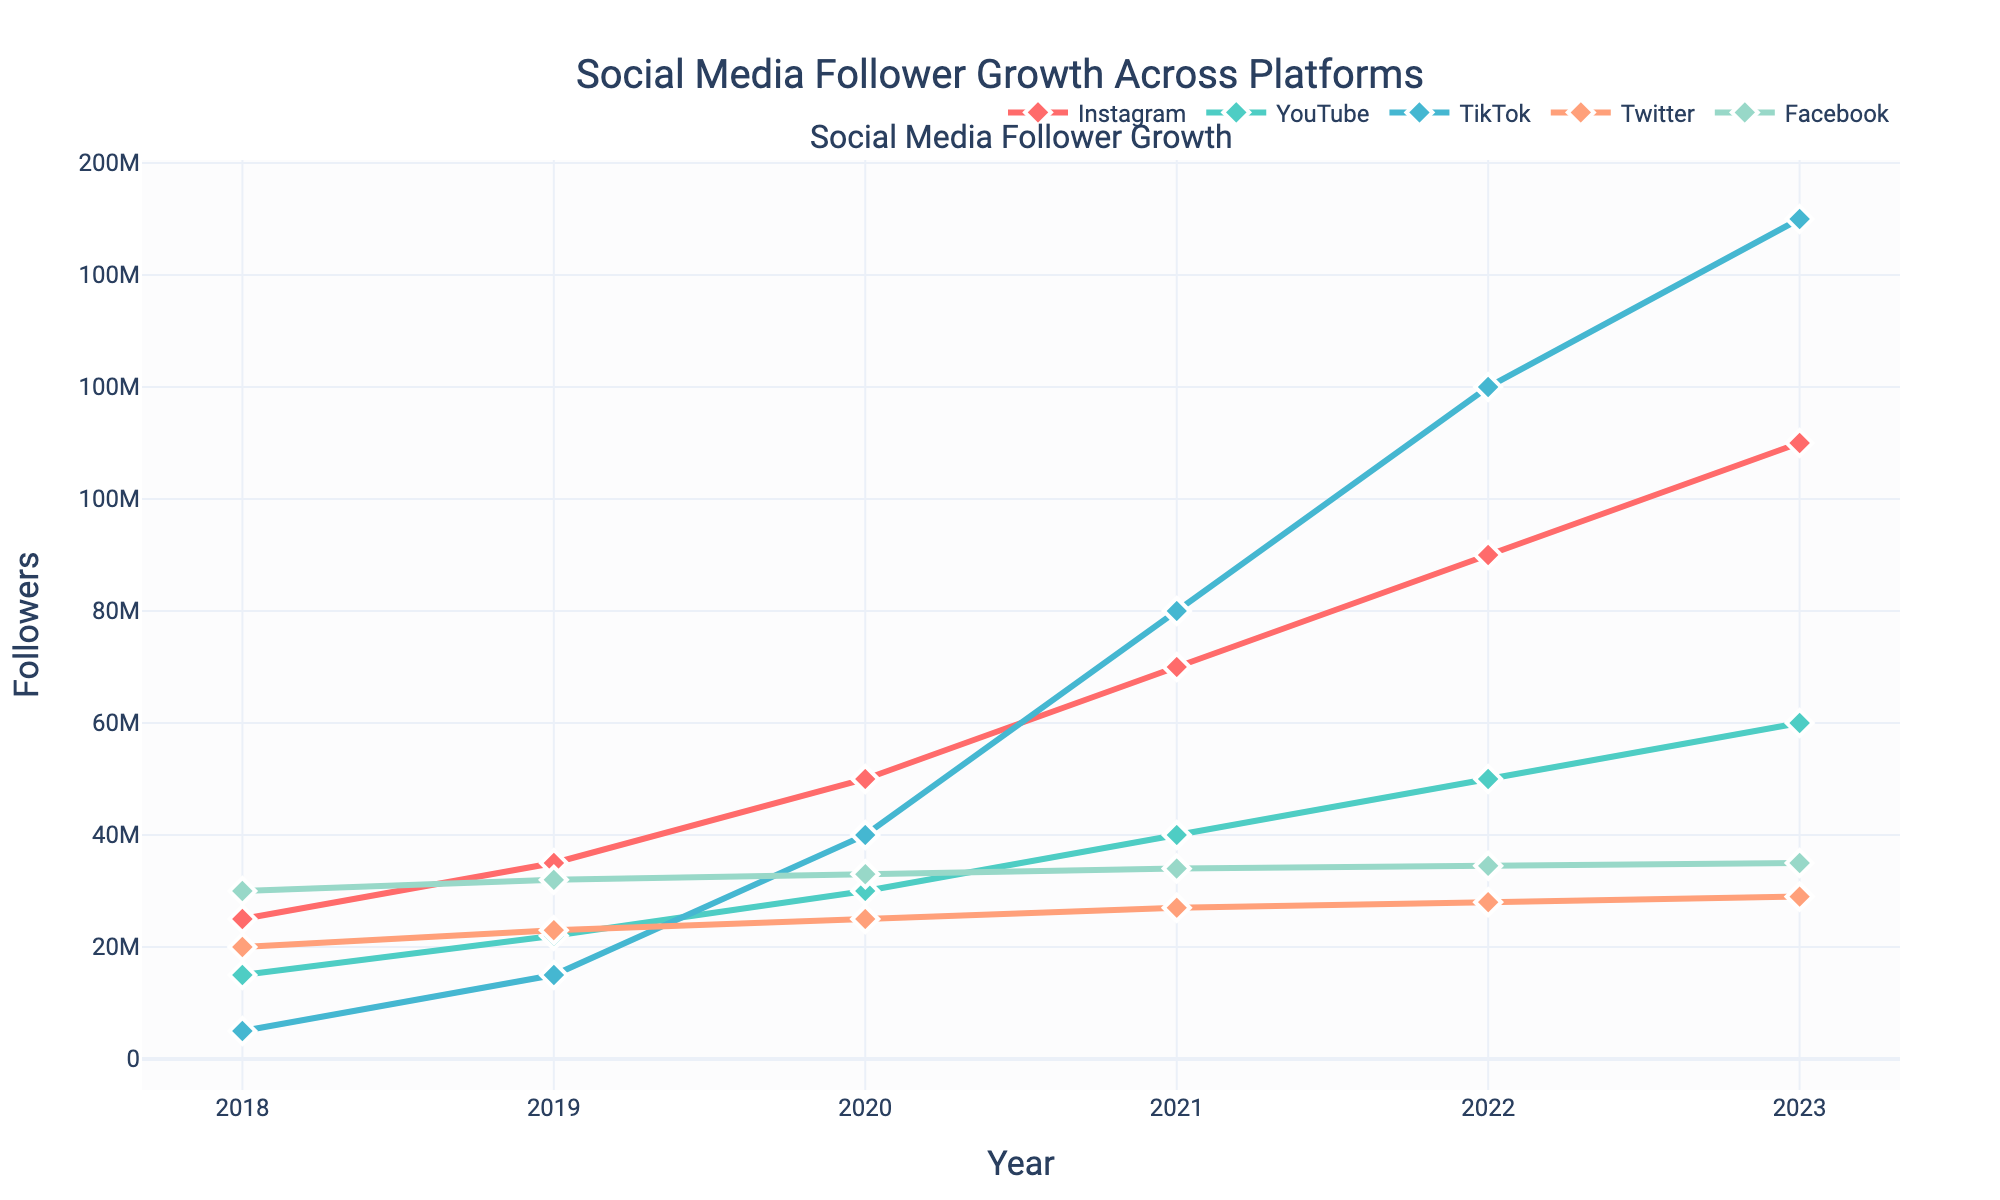What was the follower count for Instagram in 2020? Look at the line for Instagram in the year 2020; the data point shows 50,000,000 followers.
Answer: 50,000,000 How many more followers did TikTok have than YouTube in 2022? In 2022, TikTok had 120,000,000 followers and YouTube had 50,000,000. The difference is 120,000,000 - 50,000,000 = 70,000,000 followers.
Answer: 70,000,000 Which social media platform experienced the highest growth in followers between 2021 and 2023? Compare the follower counts in 2021 and 2023 for all platforms. TikTok grew from 80,000,000 to 150,000,000, yielding the highest growth of 70,000,000 followers.
Answer: TikTok What is the average follower count for Facebook over the 5 years? Add the follower counts for Facebook from 2018 to 2023 and divide by 6: (30,000,000 + 32,000,000 + 33,000,000 + 34,000,000 + 34,500,000 + 35,000,000) / 6 = 33,083,333.33
Answer: 33,083,333.33 Did Twitter’s followers grow every year? Check the follower count for Twitter each year from 2018 to 2023. It increases every year.
Answer: Yes In which year did Instagram surpass 70,000,000 followers? Look at the data points for Instagram; it surpasses 70,000,000 followers in 2021.
Answer: 2021 What was the total follower count for all platforms in 2019? Sum the follower counts for all platforms in 2019: 35,000,000 (Instagram) + 22,000,000 (YouTube) + 15,000,000 (TikTok) + 23,000,000 (Twitter) + 32,000,000 (Facebook) = 127,000,000
Answer: 127,000,000 Compare the visual appearance of the trend lines for Instagram and Twitter. Which one is steeper, and what does it indicate? The line for Instagram is steeper compared to Twitter, indicating a faster rate of increase in followers.
Answer: Instagram 